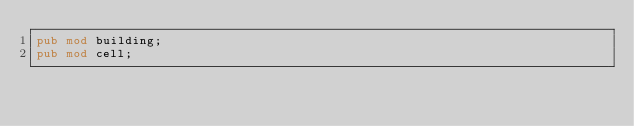Convert code to text. <code><loc_0><loc_0><loc_500><loc_500><_Rust_>pub mod building;
pub mod cell;</code> 